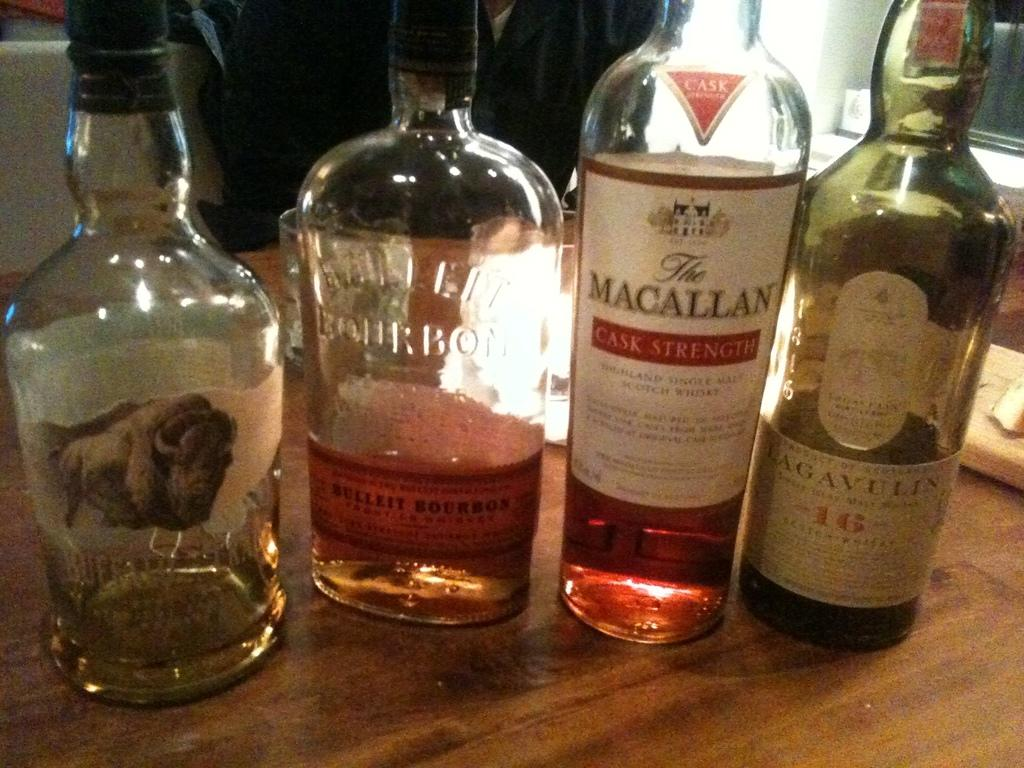<image>
Give a short and clear explanation of the subsequent image. the word macallan that is on one of the bottles 